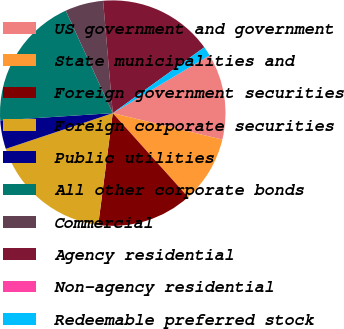Convert chart to OTSL. <chart><loc_0><loc_0><loc_500><loc_500><pie_chart><fcel>US government and government<fcel>State municipalities and<fcel>Foreign government securities<fcel>Foreign corporate securities<fcel>Public utilities<fcel>All other corporate bonds<fcel>Commercial<fcel>Agency residential<fcel>Non-agency residential<fcel>Redeemable preferred stock<nl><fcel>12.33%<fcel>9.59%<fcel>13.7%<fcel>17.81%<fcel>4.11%<fcel>19.18%<fcel>5.48%<fcel>16.44%<fcel>0.0%<fcel>1.37%<nl></chart> 